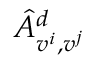Convert formula to latex. <formula><loc_0><loc_0><loc_500><loc_500>\hat { A } _ { v ^ { i } , v ^ { j } } ^ { d }</formula> 